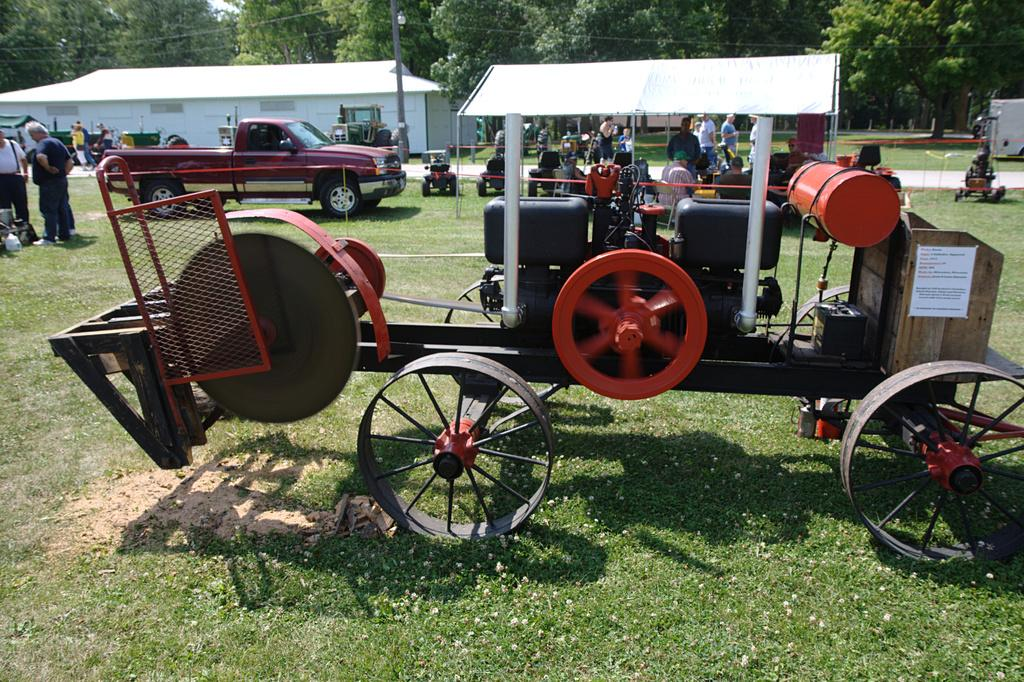What types of objects are present in the image? There are vehicles and people in the image. What can be seen at the bottom of the image? There is grass at the bottom of the image. What is visible in the background of the image? There is a building and trees in the background of the image. How many cakes are being sold by the people in the image? There is no mention of cakes in the image; it features vehicles, people, grass, a building, and trees. Can you tell me how much a dime is worth in the image? There is no reference to a dime or any monetary value in the image. 